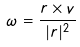Convert formula to latex. <formula><loc_0><loc_0><loc_500><loc_500>\omega = \frac { r \times v } { | r | ^ { 2 } }</formula> 